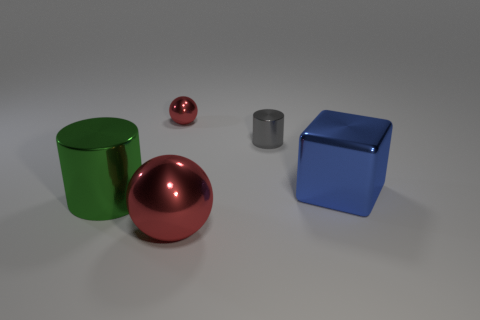Add 3 big green cylinders. How many objects exist? 8 Subtract all blocks. How many objects are left? 4 Subtract 0 brown spheres. How many objects are left? 5 Subtract all big blue shiny things. Subtract all small red metallic spheres. How many objects are left? 3 Add 1 blocks. How many blocks are left? 2 Add 2 tiny gray metallic cylinders. How many tiny gray metallic cylinders exist? 3 